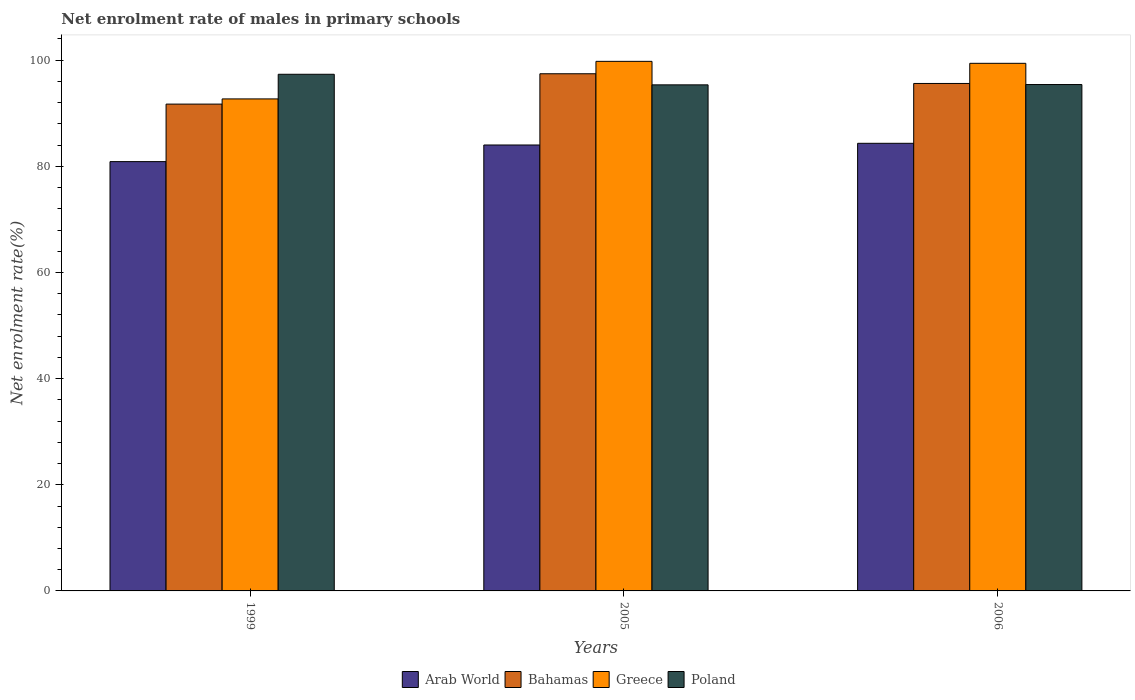How many different coloured bars are there?
Give a very brief answer. 4. Are the number of bars per tick equal to the number of legend labels?
Provide a succinct answer. Yes. Are the number of bars on each tick of the X-axis equal?
Your answer should be compact. Yes. How many bars are there on the 1st tick from the right?
Offer a very short reply. 4. In how many cases, is the number of bars for a given year not equal to the number of legend labels?
Keep it short and to the point. 0. What is the net enrolment rate of males in primary schools in Greece in 1999?
Ensure brevity in your answer.  92.7. Across all years, what is the maximum net enrolment rate of males in primary schools in Bahamas?
Provide a succinct answer. 97.44. Across all years, what is the minimum net enrolment rate of males in primary schools in Bahamas?
Your answer should be compact. 91.73. In which year was the net enrolment rate of males in primary schools in Poland maximum?
Ensure brevity in your answer.  1999. In which year was the net enrolment rate of males in primary schools in Greece minimum?
Make the answer very short. 1999. What is the total net enrolment rate of males in primary schools in Bahamas in the graph?
Offer a terse response. 284.78. What is the difference between the net enrolment rate of males in primary schools in Bahamas in 1999 and that in 2006?
Make the answer very short. -3.89. What is the difference between the net enrolment rate of males in primary schools in Arab World in 2005 and the net enrolment rate of males in primary schools in Bahamas in 2006?
Your answer should be compact. -11.59. What is the average net enrolment rate of males in primary schools in Greece per year?
Your answer should be compact. 97.3. In the year 2006, what is the difference between the net enrolment rate of males in primary schools in Bahamas and net enrolment rate of males in primary schools in Arab World?
Ensure brevity in your answer.  11.27. In how many years, is the net enrolment rate of males in primary schools in Arab World greater than 28 %?
Offer a very short reply. 3. What is the ratio of the net enrolment rate of males in primary schools in Poland in 2005 to that in 2006?
Provide a succinct answer. 1. Is the net enrolment rate of males in primary schools in Bahamas in 2005 less than that in 2006?
Keep it short and to the point. No. What is the difference between the highest and the second highest net enrolment rate of males in primary schools in Arab World?
Provide a short and direct response. 0.32. What is the difference between the highest and the lowest net enrolment rate of males in primary schools in Arab World?
Make the answer very short. 3.45. In how many years, is the net enrolment rate of males in primary schools in Bahamas greater than the average net enrolment rate of males in primary schools in Bahamas taken over all years?
Offer a very short reply. 2. Is it the case that in every year, the sum of the net enrolment rate of males in primary schools in Arab World and net enrolment rate of males in primary schools in Greece is greater than the sum of net enrolment rate of males in primary schools in Bahamas and net enrolment rate of males in primary schools in Poland?
Make the answer very short. Yes. What does the 2nd bar from the left in 2006 represents?
Make the answer very short. Bahamas. How many years are there in the graph?
Your response must be concise. 3. What is the difference between two consecutive major ticks on the Y-axis?
Provide a succinct answer. 20. Where does the legend appear in the graph?
Give a very brief answer. Bottom center. How many legend labels are there?
Offer a terse response. 4. What is the title of the graph?
Provide a succinct answer. Net enrolment rate of males in primary schools. What is the label or title of the Y-axis?
Offer a terse response. Net enrolment rate(%). What is the Net enrolment rate(%) in Arab World in 1999?
Provide a succinct answer. 80.89. What is the Net enrolment rate(%) of Bahamas in 1999?
Your response must be concise. 91.73. What is the Net enrolment rate(%) of Greece in 1999?
Give a very brief answer. 92.7. What is the Net enrolment rate(%) of Poland in 1999?
Ensure brevity in your answer.  97.35. What is the Net enrolment rate(%) in Arab World in 2005?
Provide a short and direct response. 84.02. What is the Net enrolment rate(%) in Bahamas in 2005?
Keep it short and to the point. 97.44. What is the Net enrolment rate(%) in Greece in 2005?
Keep it short and to the point. 99.78. What is the Net enrolment rate(%) in Poland in 2005?
Your answer should be compact. 95.35. What is the Net enrolment rate(%) of Arab World in 2006?
Offer a very short reply. 84.34. What is the Net enrolment rate(%) in Bahamas in 2006?
Make the answer very short. 95.61. What is the Net enrolment rate(%) of Greece in 2006?
Your answer should be very brief. 99.41. What is the Net enrolment rate(%) in Poland in 2006?
Provide a short and direct response. 95.41. Across all years, what is the maximum Net enrolment rate(%) in Arab World?
Give a very brief answer. 84.34. Across all years, what is the maximum Net enrolment rate(%) in Bahamas?
Your answer should be compact. 97.44. Across all years, what is the maximum Net enrolment rate(%) of Greece?
Provide a short and direct response. 99.78. Across all years, what is the maximum Net enrolment rate(%) of Poland?
Your answer should be compact. 97.35. Across all years, what is the minimum Net enrolment rate(%) in Arab World?
Your response must be concise. 80.89. Across all years, what is the minimum Net enrolment rate(%) of Bahamas?
Make the answer very short. 91.73. Across all years, what is the minimum Net enrolment rate(%) in Greece?
Keep it short and to the point. 92.7. Across all years, what is the minimum Net enrolment rate(%) in Poland?
Give a very brief answer. 95.35. What is the total Net enrolment rate(%) of Arab World in the graph?
Your answer should be compact. 249.25. What is the total Net enrolment rate(%) of Bahamas in the graph?
Offer a very short reply. 284.78. What is the total Net enrolment rate(%) of Greece in the graph?
Keep it short and to the point. 291.89. What is the total Net enrolment rate(%) in Poland in the graph?
Ensure brevity in your answer.  288.11. What is the difference between the Net enrolment rate(%) of Arab World in 1999 and that in 2005?
Offer a very short reply. -3.13. What is the difference between the Net enrolment rate(%) of Bahamas in 1999 and that in 2005?
Offer a terse response. -5.72. What is the difference between the Net enrolment rate(%) in Greece in 1999 and that in 2005?
Provide a succinct answer. -7.08. What is the difference between the Net enrolment rate(%) in Poland in 1999 and that in 2005?
Offer a very short reply. 1.99. What is the difference between the Net enrolment rate(%) of Arab World in 1999 and that in 2006?
Ensure brevity in your answer.  -3.45. What is the difference between the Net enrolment rate(%) of Bahamas in 1999 and that in 2006?
Provide a succinct answer. -3.89. What is the difference between the Net enrolment rate(%) in Greece in 1999 and that in 2006?
Your answer should be very brief. -6.71. What is the difference between the Net enrolment rate(%) of Poland in 1999 and that in 2006?
Your answer should be compact. 1.93. What is the difference between the Net enrolment rate(%) of Arab World in 2005 and that in 2006?
Ensure brevity in your answer.  -0.32. What is the difference between the Net enrolment rate(%) of Bahamas in 2005 and that in 2006?
Provide a short and direct response. 1.83. What is the difference between the Net enrolment rate(%) in Greece in 2005 and that in 2006?
Provide a succinct answer. 0.37. What is the difference between the Net enrolment rate(%) of Poland in 2005 and that in 2006?
Your answer should be compact. -0.06. What is the difference between the Net enrolment rate(%) of Arab World in 1999 and the Net enrolment rate(%) of Bahamas in 2005?
Your answer should be very brief. -16.56. What is the difference between the Net enrolment rate(%) of Arab World in 1999 and the Net enrolment rate(%) of Greece in 2005?
Make the answer very short. -18.89. What is the difference between the Net enrolment rate(%) of Arab World in 1999 and the Net enrolment rate(%) of Poland in 2005?
Ensure brevity in your answer.  -14.46. What is the difference between the Net enrolment rate(%) in Bahamas in 1999 and the Net enrolment rate(%) in Greece in 2005?
Provide a succinct answer. -8.05. What is the difference between the Net enrolment rate(%) in Bahamas in 1999 and the Net enrolment rate(%) in Poland in 2005?
Offer a very short reply. -3.63. What is the difference between the Net enrolment rate(%) of Greece in 1999 and the Net enrolment rate(%) of Poland in 2005?
Provide a short and direct response. -2.65. What is the difference between the Net enrolment rate(%) of Arab World in 1999 and the Net enrolment rate(%) of Bahamas in 2006?
Make the answer very short. -14.73. What is the difference between the Net enrolment rate(%) in Arab World in 1999 and the Net enrolment rate(%) in Greece in 2006?
Keep it short and to the point. -18.52. What is the difference between the Net enrolment rate(%) in Arab World in 1999 and the Net enrolment rate(%) in Poland in 2006?
Provide a short and direct response. -14.53. What is the difference between the Net enrolment rate(%) in Bahamas in 1999 and the Net enrolment rate(%) in Greece in 2006?
Provide a succinct answer. -7.68. What is the difference between the Net enrolment rate(%) of Bahamas in 1999 and the Net enrolment rate(%) of Poland in 2006?
Provide a short and direct response. -3.69. What is the difference between the Net enrolment rate(%) of Greece in 1999 and the Net enrolment rate(%) of Poland in 2006?
Your answer should be compact. -2.71. What is the difference between the Net enrolment rate(%) of Arab World in 2005 and the Net enrolment rate(%) of Bahamas in 2006?
Offer a very short reply. -11.59. What is the difference between the Net enrolment rate(%) in Arab World in 2005 and the Net enrolment rate(%) in Greece in 2006?
Your answer should be very brief. -15.39. What is the difference between the Net enrolment rate(%) in Arab World in 2005 and the Net enrolment rate(%) in Poland in 2006?
Keep it short and to the point. -11.39. What is the difference between the Net enrolment rate(%) in Bahamas in 2005 and the Net enrolment rate(%) in Greece in 2006?
Your response must be concise. -1.97. What is the difference between the Net enrolment rate(%) of Bahamas in 2005 and the Net enrolment rate(%) of Poland in 2006?
Make the answer very short. 2.03. What is the difference between the Net enrolment rate(%) of Greece in 2005 and the Net enrolment rate(%) of Poland in 2006?
Ensure brevity in your answer.  4.37. What is the average Net enrolment rate(%) of Arab World per year?
Offer a very short reply. 83.08. What is the average Net enrolment rate(%) in Bahamas per year?
Your answer should be very brief. 94.93. What is the average Net enrolment rate(%) of Greece per year?
Your answer should be compact. 97.3. What is the average Net enrolment rate(%) in Poland per year?
Offer a very short reply. 96.04. In the year 1999, what is the difference between the Net enrolment rate(%) in Arab World and Net enrolment rate(%) in Bahamas?
Ensure brevity in your answer.  -10.84. In the year 1999, what is the difference between the Net enrolment rate(%) in Arab World and Net enrolment rate(%) in Greece?
Provide a short and direct response. -11.82. In the year 1999, what is the difference between the Net enrolment rate(%) in Arab World and Net enrolment rate(%) in Poland?
Your answer should be compact. -16.46. In the year 1999, what is the difference between the Net enrolment rate(%) of Bahamas and Net enrolment rate(%) of Greece?
Make the answer very short. -0.98. In the year 1999, what is the difference between the Net enrolment rate(%) in Bahamas and Net enrolment rate(%) in Poland?
Your answer should be compact. -5.62. In the year 1999, what is the difference between the Net enrolment rate(%) of Greece and Net enrolment rate(%) of Poland?
Provide a short and direct response. -4.64. In the year 2005, what is the difference between the Net enrolment rate(%) of Arab World and Net enrolment rate(%) of Bahamas?
Offer a terse response. -13.42. In the year 2005, what is the difference between the Net enrolment rate(%) of Arab World and Net enrolment rate(%) of Greece?
Ensure brevity in your answer.  -15.76. In the year 2005, what is the difference between the Net enrolment rate(%) of Arab World and Net enrolment rate(%) of Poland?
Ensure brevity in your answer.  -11.33. In the year 2005, what is the difference between the Net enrolment rate(%) of Bahamas and Net enrolment rate(%) of Greece?
Ensure brevity in your answer.  -2.34. In the year 2005, what is the difference between the Net enrolment rate(%) of Bahamas and Net enrolment rate(%) of Poland?
Provide a succinct answer. 2.09. In the year 2005, what is the difference between the Net enrolment rate(%) in Greece and Net enrolment rate(%) in Poland?
Offer a very short reply. 4.43. In the year 2006, what is the difference between the Net enrolment rate(%) in Arab World and Net enrolment rate(%) in Bahamas?
Provide a succinct answer. -11.27. In the year 2006, what is the difference between the Net enrolment rate(%) in Arab World and Net enrolment rate(%) in Greece?
Offer a very short reply. -15.07. In the year 2006, what is the difference between the Net enrolment rate(%) in Arab World and Net enrolment rate(%) in Poland?
Offer a terse response. -11.07. In the year 2006, what is the difference between the Net enrolment rate(%) of Bahamas and Net enrolment rate(%) of Greece?
Give a very brief answer. -3.8. In the year 2006, what is the difference between the Net enrolment rate(%) of Bahamas and Net enrolment rate(%) of Poland?
Keep it short and to the point. 0.2. In the year 2006, what is the difference between the Net enrolment rate(%) of Greece and Net enrolment rate(%) of Poland?
Provide a succinct answer. 4. What is the ratio of the Net enrolment rate(%) in Arab World in 1999 to that in 2005?
Offer a terse response. 0.96. What is the ratio of the Net enrolment rate(%) in Bahamas in 1999 to that in 2005?
Provide a succinct answer. 0.94. What is the ratio of the Net enrolment rate(%) in Greece in 1999 to that in 2005?
Make the answer very short. 0.93. What is the ratio of the Net enrolment rate(%) of Poland in 1999 to that in 2005?
Keep it short and to the point. 1.02. What is the ratio of the Net enrolment rate(%) of Arab World in 1999 to that in 2006?
Provide a short and direct response. 0.96. What is the ratio of the Net enrolment rate(%) of Bahamas in 1999 to that in 2006?
Your response must be concise. 0.96. What is the ratio of the Net enrolment rate(%) of Greece in 1999 to that in 2006?
Your answer should be very brief. 0.93. What is the ratio of the Net enrolment rate(%) in Poland in 1999 to that in 2006?
Offer a very short reply. 1.02. What is the ratio of the Net enrolment rate(%) of Bahamas in 2005 to that in 2006?
Make the answer very short. 1.02. What is the ratio of the Net enrolment rate(%) in Greece in 2005 to that in 2006?
Provide a short and direct response. 1. What is the difference between the highest and the second highest Net enrolment rate(%) of Arab World?
Give a very brief answer. 0.32. What is the difference between the highest and the second highest Net enrolment rate(%) in Bahamas?
Provide a succinct answer. 1.83. What is the difference between the highest and the second highest Net enrolment rate(%) of Greece?
Provide a short and direct response. 0.37. What is the difference between the highest and the second highest Net enrolment rate(%) of Poland?
Make the answer very short. 1.93. What is the difference between the highest and the lowest Net enrolment rate(%) in Arab World?
Make the answer very short. 3.45. What is the difference between the highest and the lowest Net enrolment rate(%) of Bahamas?
Your response must be concise. 5.72. What is the difference between the highest and the lowest Net enrolment rate(%) of Greece?
Keep it short and to the point. 7.08. What is the difference between the highest and the lowest Net enrolment rate(%) in Poland?
Give a very brief answer. 1.99. 